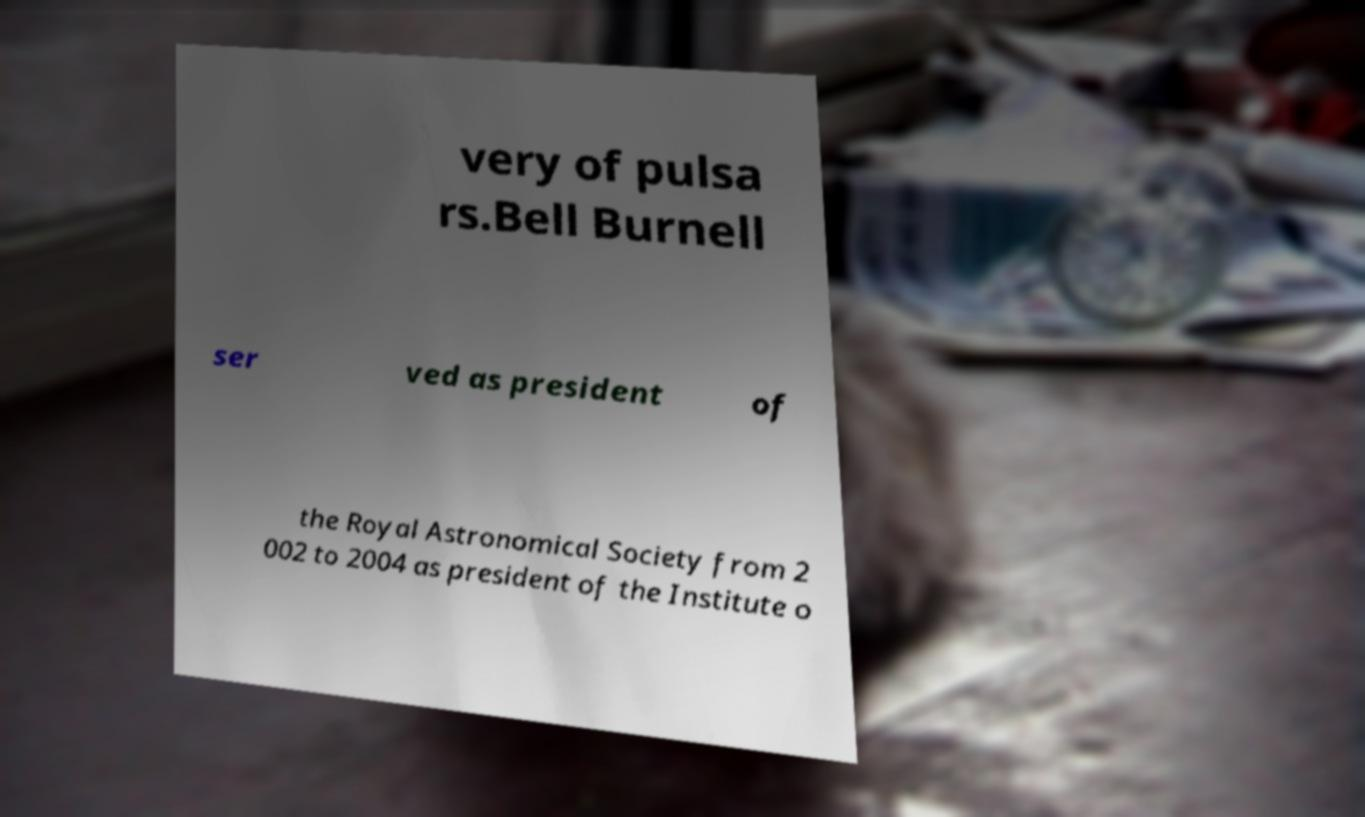I need the written content from this picture converted into text. Can you do that? very of pulsa rs.Bell Burnell ser ved as president of the Royal Astronomical Society from 2 002 to 2004 as president of the Institute o 